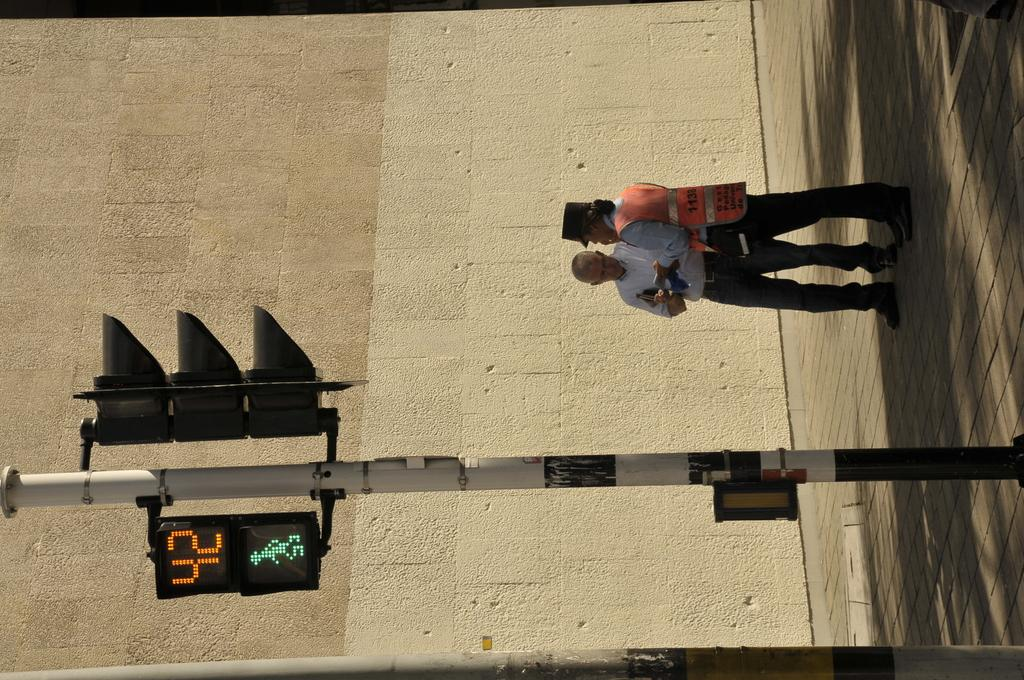What is the main object in the image? There is a pole in the image. What is attached to the pole? Traffic signals are present on the pole. How many people can be seen in the image? There are 2 people standing in the image. What can be seen in the background of the image? There is a wall in the background of the image. What type of chin can be seen on the pancake in the image? There is no pancake or chin present in the image. How many cows are visible in the image? There are no cows visible in the image. 